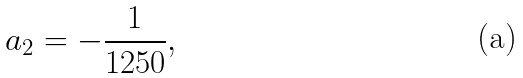Convert formula to latex. <formula><loc_0><loc_0><loc_500><loc_500>a _ { 2 } = - \frac { 1 } { 1 2 5 0 } ,</formula> 